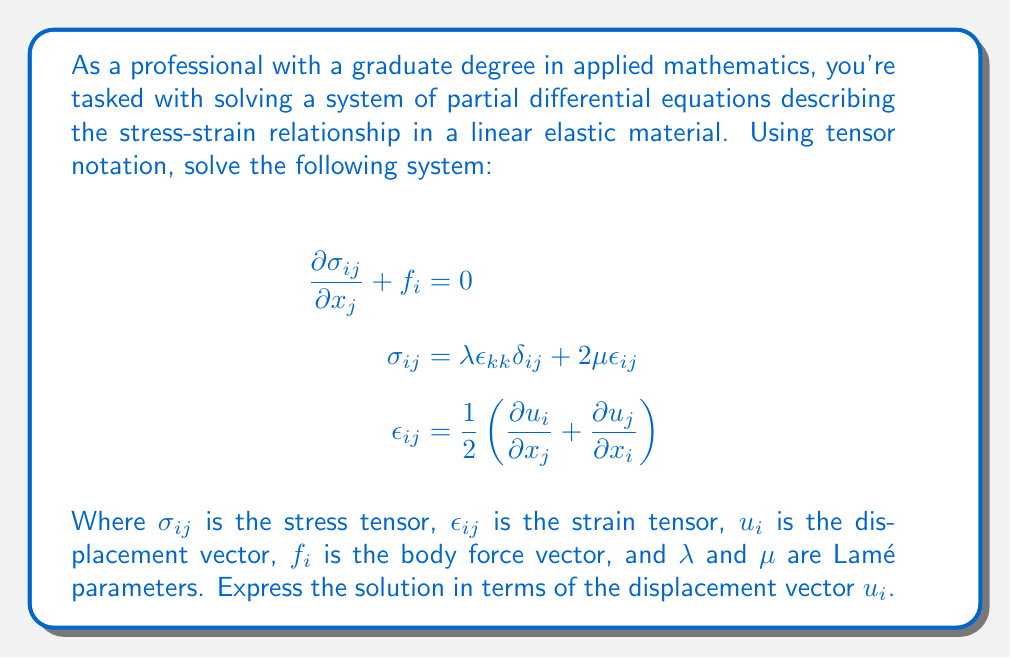Solve this math problem. To solve this system of equations, we'll follow these steps:

1) First, we substitute the strain tensor equation into the stress-strain relationship:

   $$\sigma_{ij} = \lambda \epsilon_{kk} \delta_{ij} + 2\mu \epsilon_{ij}$$
   $$\sigma_{ij} = \lambda \frac{\partial u_k}{\partial x_k} \delta_{ij} + \mu\left(\frac{\partial u_i}{\partial x_j} + \frac{\partial u_j}{\partial x_i}\right)$$

2) Now, we substitute this expression into the equilibrium equation:

   $$\frac{\partial}{\partial x_j}\left[\lambda \frac{\partial u_k}{\partial x_k} \delta_{ij} + \mu\left(\frac{\partial u_i}{\partial x_j} + \frac{\partial u_j}{\partial x_i}\right)\right] + f_i = 0$$

3) Expanding this equation:

   $$\lambda \frac{\partial^2 u_k}{\partial x_i \partial x_k} + \mu\frac{\partial^2 u_i}{\partial x_j \partial x_j} + \mu\frac{\partial^2 u_j}{\partial x_i \partial x_j} + f_i = 0$$

4) We can simplify this further by noting that $\frac{\partial^2 u_k}{\partial x_i \partial x_k} = \frac{\partial^2 u_i}{\partial x_k \partial x_k}$ (assuming sufficient smoothness of $u_i$):

   $$\lambda \frac{\partial^2 u_i}{\partial x_k \partial x_k} + \mu\frac{\partial^2 u_i}{\partial x_j \partial x_j} + \mu\frac{\partial^2 u_j}{\partial x_i \partial x_j} + f_i = 0$$

5) Rearranging terms:

   $$(\lambda + \mu)\frac{\partial^2 u_i}{\partial x_k \partial x_k} + \mu\frac{\partial^2 u_i}{\partial x_j \partial x_j} + f_i = 0$$

6) We can write this more compactly using the Laplacian operator $\nabla^2$:

   $$(\lambda + \mu)\frac{\partial}{\partial x_i}(\nabla \cdot \mathbf{u}) + \mu\nabla^2 u_i + f_i = 0$$

This is the Navier-Cauchy equation, which is the final form of our solution in terms of the displacement vector $u_i$.
Answer: $(\lambda + \mu)\frac{\partial}{\partial x_i}(\nabla \cdot \mathbf{u}) + \mu\nabla^2 u_i + f_i = 0$ 